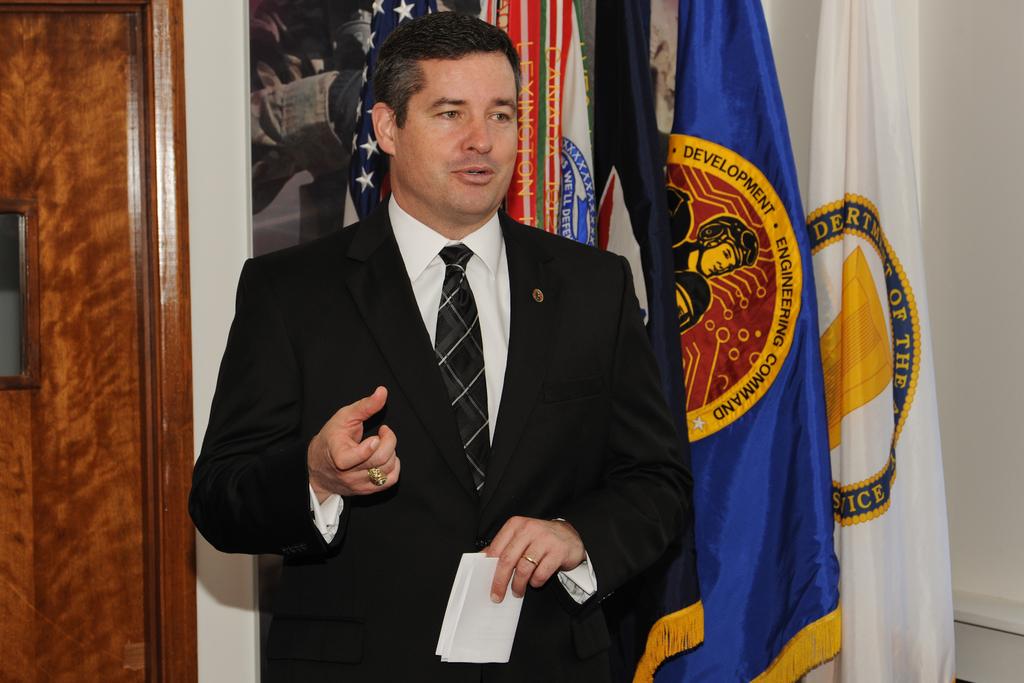What are the words on the blue flag behind the man?
Make the answer very short. Development engineering command. What city is written on the red thing behind his head?
Keep it short and to the point. Lexington. 